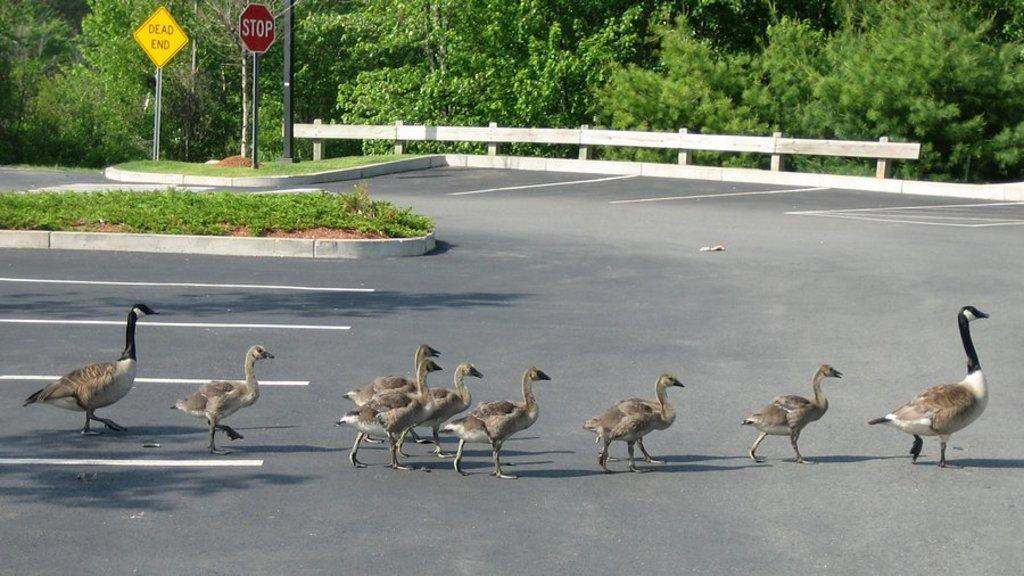What animals can be seen in the image? There is a group of ducks in the image. What are the ducks doing in the image? The ducks are walking on the road. What type of vegetation is visible in the image? There is grass visible in the image. What structures can be seen in the image? There are two sign boards attached to poles in the image. What type of trees are present in the image? There are trees with branches and leaves in the image. What type of cake is being served at the top of the tree in the image? There is no cake present in the image; it features a group of ducks walking on the road. Can you tell me how many zippers are attached to the trees in the image? There are no zippers present in the image; it features trees with branches and leaves. 